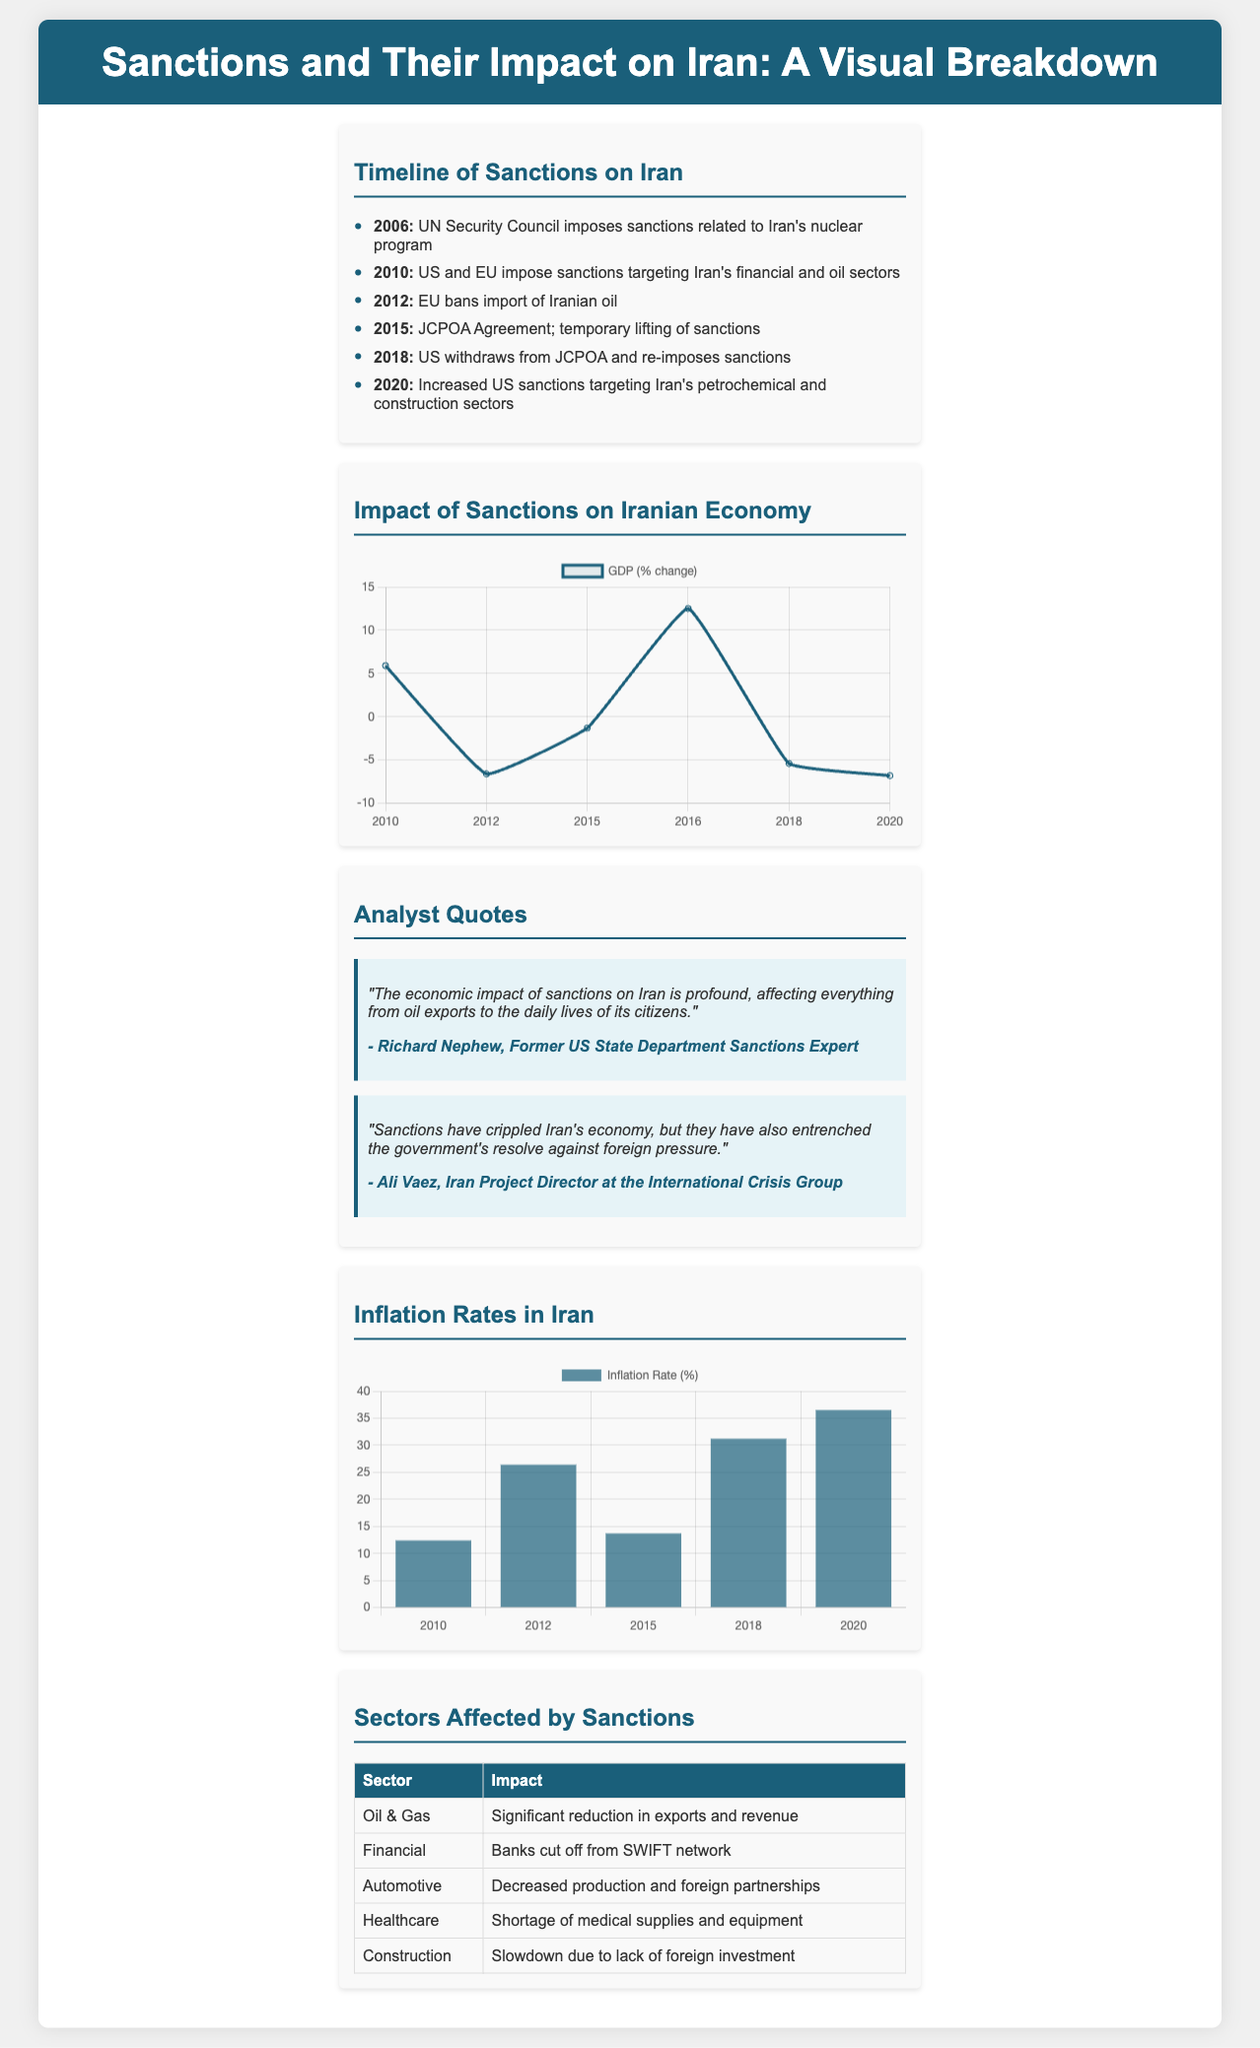What year did the US and EU impose sanctions targeting Iran's financial and oil sectors? The timeline section indicates that US and EU sanctions targeting Iran's financial and oil sectors were imposed in 2010.
Answer: 2010 What was the GDP change in Iran in 2018? The GDP chart shows that the GDP change in Iran in 2018 was -5.4 percent.
Answer: -5.4 Which sector experienced a significant reduction in exports and revenue? The sectors affected by sanctions table specifies that the Oil & Gas sector experienced a significant reduction in exports and revenue.
Answer: Oil & Gas What was the inflation rate in Iran in 2020? The inflation chart indicates that the inflation rate in Iran in 2020 was 36.5 percent.
Answer: 36.5 Who stated that the economic impact of sanctions on Iran is profound? The analyst quotes section attributes the statement about the economic impact of sanctions being profound to Richard Nephew.
Answer: Richard Nephew In what year was the EU ban on the import of Iranian oil implemented? The timeline section notes that the EU banned the import of Iranian oil in 2012.
Answer: 2012 What effect did sanctions have on Iran's healthcare sector according to the document? The sectors affected by sanctions table details that the healthcare sector faced a shortage of medical supplies and equipment.
Answer: Shortage of medical supplies and equipment 